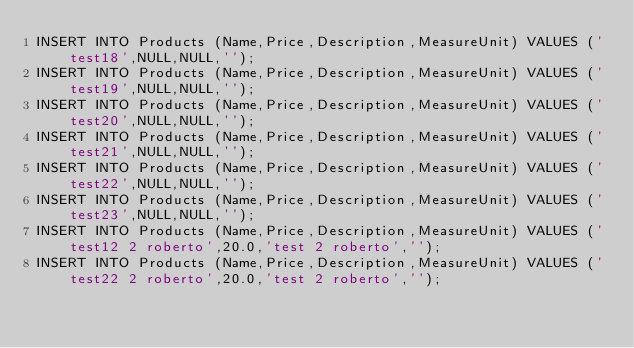<code> <loc_0><loc_0><loc_500><loc_500><_SQL_>INSERT INTO Products (Name,Price,Description,MeasureUnit) VALUES ('test18',NULL,NULL,'');
INSERT INTO Products (Name,Price,Description,MeasureUnit) VALUES ('test19',NULL,NULL,'');
INSERT INTO Products (Name,Price,Description,MeasureUnit) VALUES ('test20',NULL,NULL,'');
INSERT INTO Products (Name,Price,Description,MeasureUnit) VALUES ('test21',NULL,NULL,'');
INSERT INTO Products (Name,Price,Description,MeasureUnit) VALUES ('test22',NULL,NULL,'');
INSERT INTO Products (Name,Price,Description,MeasureUnit) VALUES ('test23',NULL,NULL,'');
INSERT INTO Products (Name,Price,Description,MeasureUnit) VALUES ('test12 2 roberto',20.0,'test 2 roberto','');
INSERT INTO Products (Name,Price,Description,MeasureUnit) VALUES ('test22 2 roberto',20.0,'test 2 roberto','');</code> 